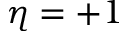Convert formula to latex. <formula><loc_0><loc_0><loc_500><loc_500>\eta = + 1</formula> 